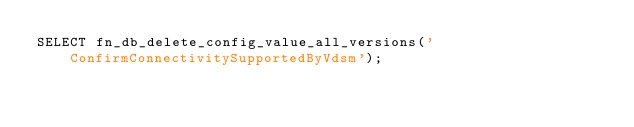<code> <loc_0><loc_0><loc_500><loc_500><_SQL_>SELECT fn_db_delete_config_value_all_versions('ConfirmConnectivitySupportedByVdsm');
</code> 